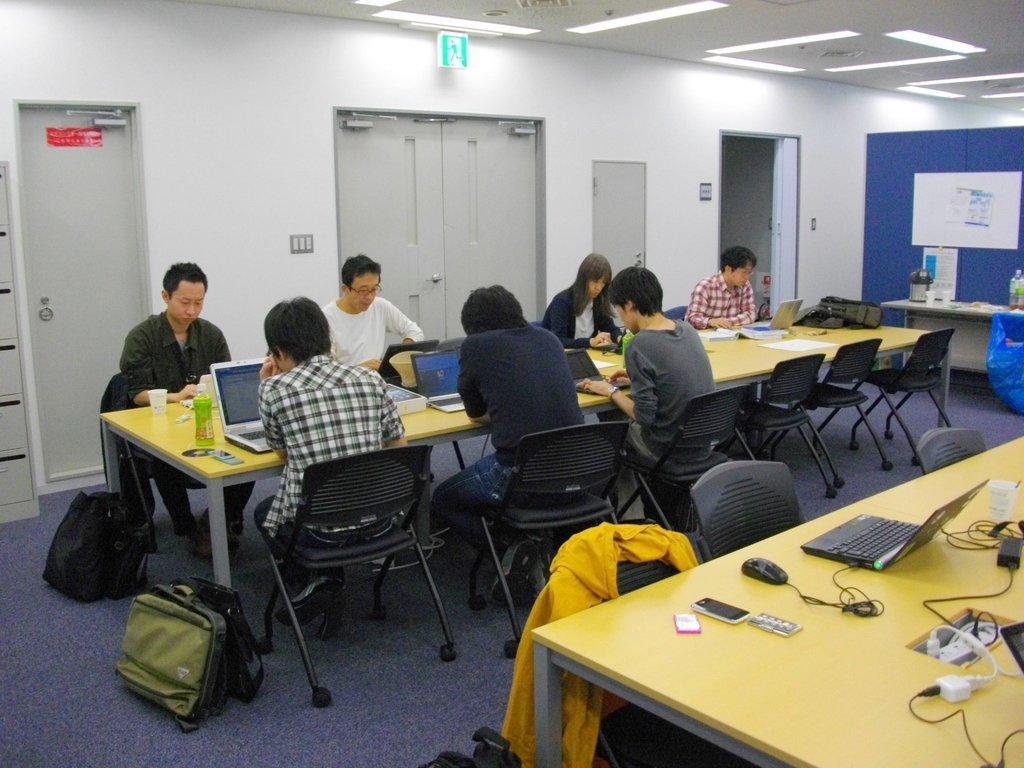Could you give a brief overview of what you see in this image? In this image there are group of persons sitting in a room doing some work with their laptops at the left side of the image there are bags and at the background of the image there is a wall and door at the right side of the image there are laptops,mobile phones on the table. 